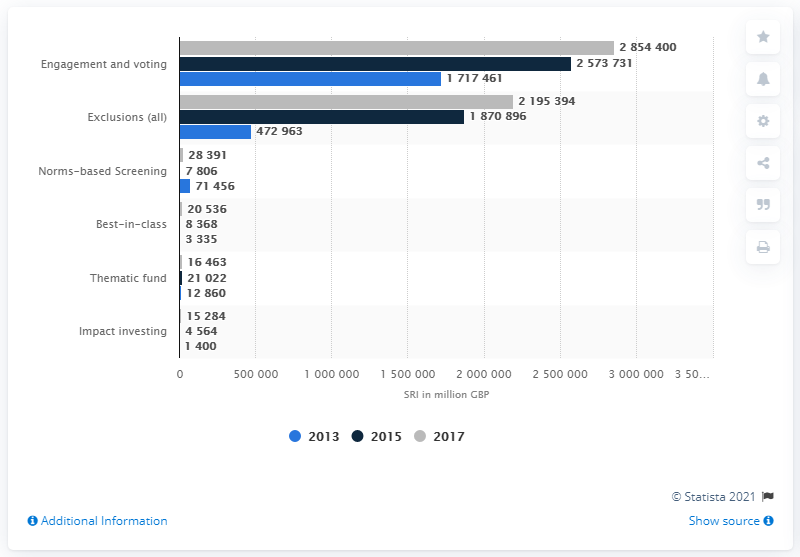Specify some key components in this picture. To the best of my knowledge, the investment in engagement programs was approximately 285,4400. 